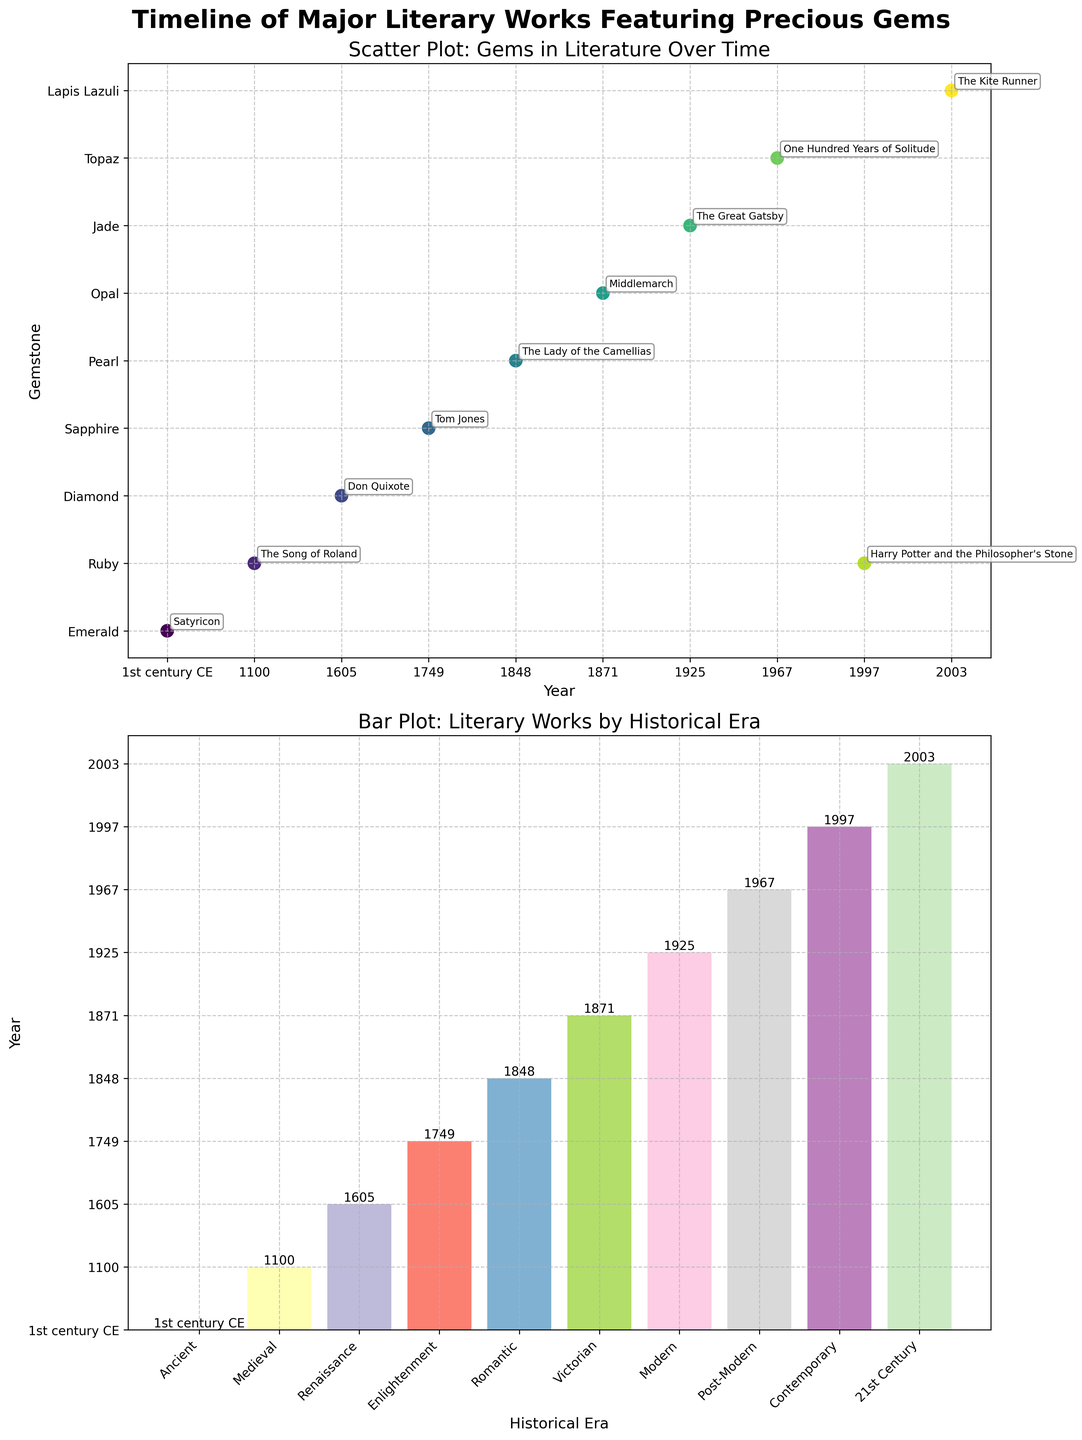what is the title of the scatter plot? The title of the scatter plot is written at the top of the first subplot. It reads "Scatter Plot: Gems in Literature Over Time".
Answer: Scatter Plot: Gems in Literature Over Time Which historical era has the earliest literary work featuring a precious gemstone? The bar plot shows "Ancient" as the era with the earliest literary work, dated to the 1st century CE.
Answer: Ancient In the scatter plot, which gemstone is associated with the novel "Tom Jones"? Find the annotation "Tom Jones" in the scatter plot and see the gemstone it points to, which is "Sapphire".
Answer: Sapphire How many novels featuring gemstones are from the 20th century or later? From the bar plot, identify the bars representing the eras from the 20th century onwards: "Modern" (1925), "Post-Modern" (1967), "Contemporary" (1997), and "21st Century" (2003). There are four such novels.
Answer: 4 Which historical era has the most recently published novel in the dataset? The bar plot shows that the "21st Century" era has the most recent publication year, 2003.
Answer: 21st Century What is the median publication year of the novels displayed in the scatter plot? Arrange the years in ascending order: 1, 1100, 1605, 1749, 1848, 1871, 1925, 1967, 1997, 2003. The median (middle value) is at the 5th and 6th positions, which are (1848 + 1871)/2 = 1859.5
Answer: 1859.5 Compare the gemstones in the "Contemporary" and "Medieval" eras. Which is rarer today? The scatter plot shows "Ruby" under "Contemporary" and "Ruby" under "Medieval". Since both contain rubies, they are equally represented. However, in general, rubies are very rare today.
Answer: Ruby Which novel's gemstone is plotted the highest in the scatter plot? The scatter plot’s y-axis represents gemstones. The novel plotted at the highest y-value corresponds to "Ruby" twice due to "The Song of Roland" and "Harry Potter and the Philosopher's Stone".
Answer: Ruby What era did the novel "Middlemarch" belong to and what was its gemstone? The scatter plot shows the novel "Middlemarch" annotated with "Opal" and from the bar plot, it falls under the 'Victorian' era, published in 1871.
Answer: Victorian, Opal What’s the range of the publication years for the novels in the dataset? From the scatter plot, the earliest year is 1st century CE, and the latest is 2003. Therefore, the range is 2003 - (-99) (since 1st century CE can be considered as year 1 CE) = 2002 years.
Answer: 2002 years 